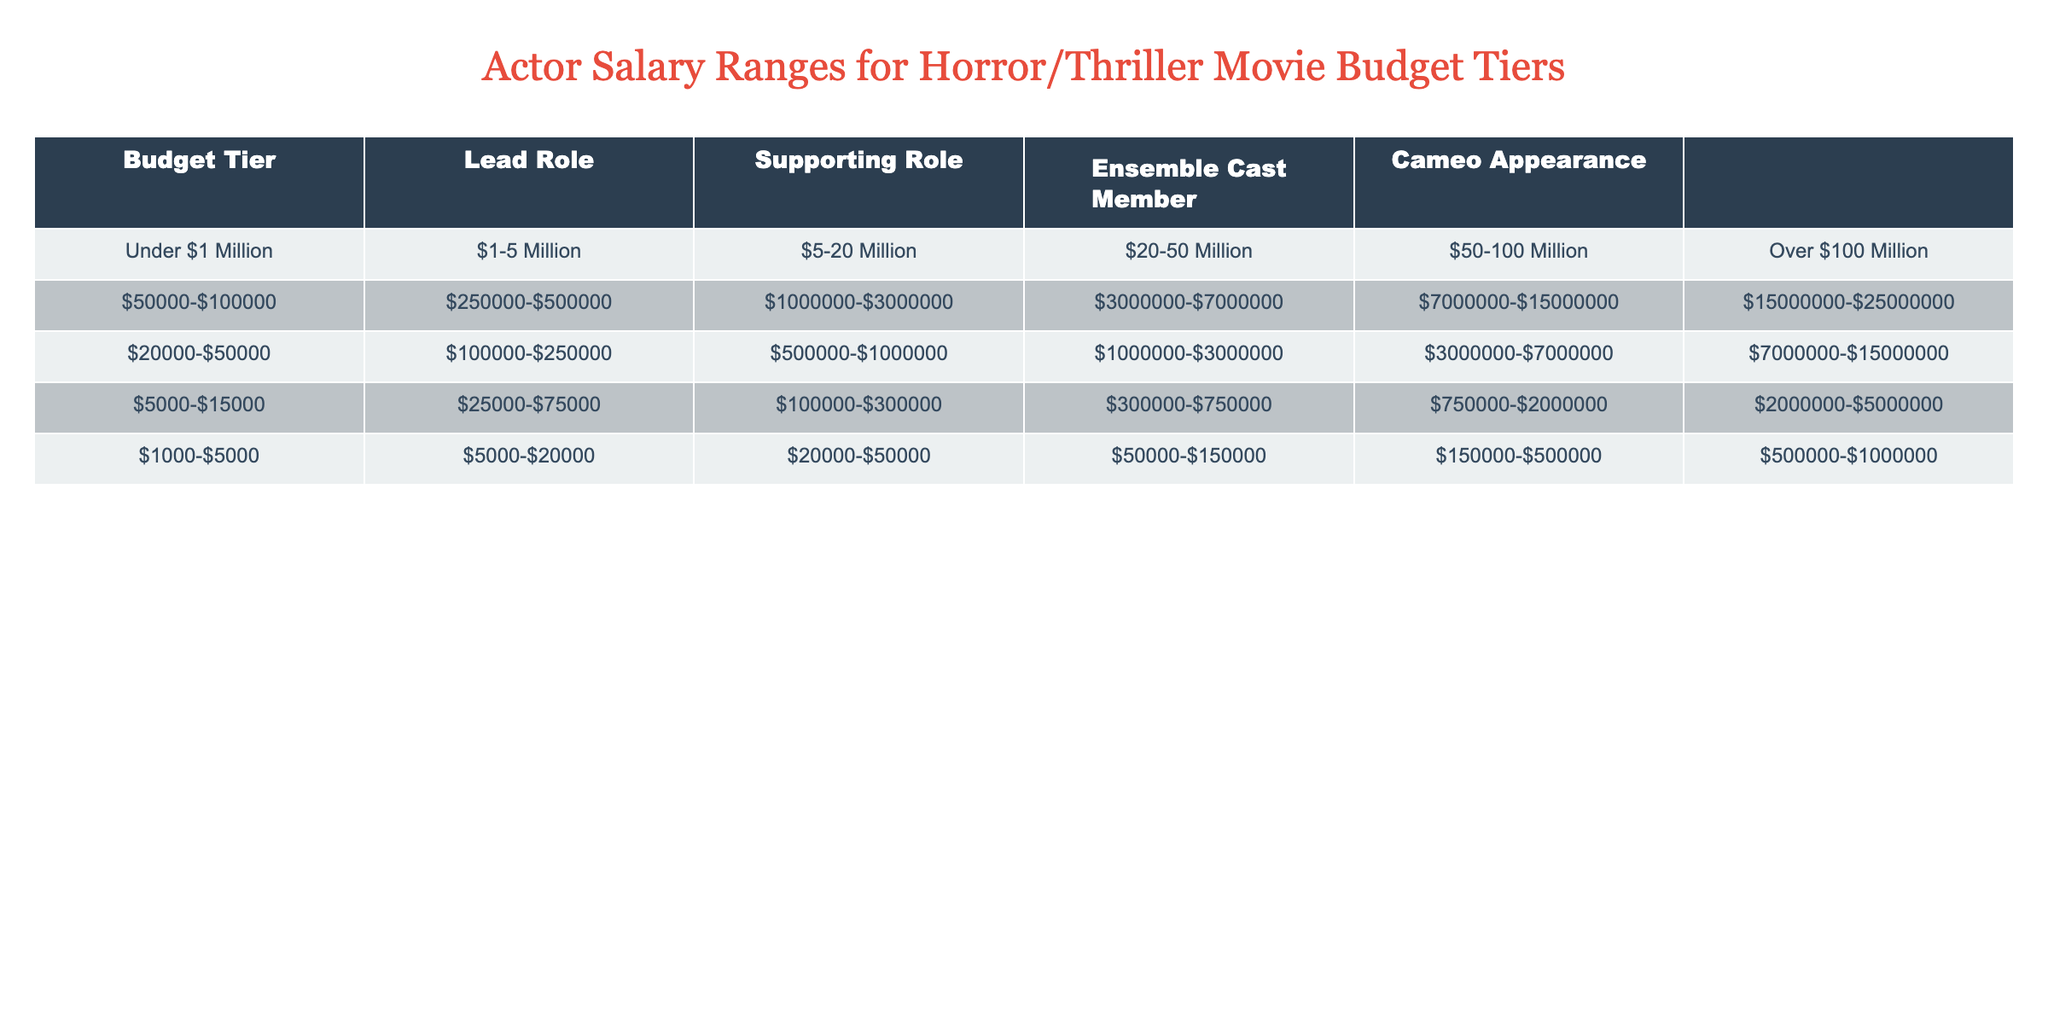What is the salary range for a lead role in movies with a budget of $1-5 million? According to the table, the salary range for a lead role in the $1-5 million budget tier is $250,000 to $500,000
Answer: $250,000-$500,000 What is the salary range for a cameo appearance in films with a budget over $100 million? The table shows that for a cameo appearance in movies with a budget over $100 million, the salary range is $500,000 to $1,000,000
Answer: $500,000-$1,000,000 For a movie budgeted between $5-20 million, how much does an ensemble cast member earn on average? The salary range for an ensemble cast member is $100,000 to $300,000. To find the average, sum the min and max values: (100,000 + 300,000) / 2 = 200,000
Answer: $200,000 Is the salary for a supporting role in the $20-50 million budget tier higher than in the $1-5 million tier? Yes, the supporting role salary in the $20-50 million tier is $1,000,000 to $3,000,000, which is significantly higher than the $100,000 to $250,000 range in the $1-5 million tier
Answer: Yes What is the difference in the maximum salary between a lead role in the $50-100 million tier and a supporting role in the $5-20 million tier? The maximum salary for a lead role in the $50-100 million tier is $15,000,000, while the maximum for a supporting role in the $5-20 million tier is $1,000,000. The difference is $15,000,000 - $1,000,000 = $14,000,000
Answer: $14,000,000 For a cameo appearance in a film with a budget of $20 million, is it possible to earn more than $100,000? No, the salary for a cameo appearance in the $20-50 million budget tier ranges between $50,000 and $150,000, which does not reach $100,000
Answer: No What is the combined salary range for a lead role in the under $1 million tier and a supporting role in the $5-20 million tier? The lead role in the under $1 million tier has a salary range of $50,000 to $100,000, and the supporting role in the $5-20 million tier ranges from $500,000 to $1,000,000. The combined range would go from $50,000 + $500,000 = $550,000 to $100,000 + $1,000,000 = $1,100,000
Answer: $550,000-$1,100,000 What percentage of the maximum salary for an ensemble cast member in the over $100 million tier is represented by the minimum salary for a supporting role in the $50-100 million tier? The maximum salary for an ensemble cast member in the over $100 million tier is $5,000,000. The minimum salary for a supporting role in the $50-100 million tier is $3,000,000. To find the percentage, calculate (3,000,000 / 5,000,000) * 100 = 60%
Answer: 60% Is it true that for every budget tier, the lead role always has a higher salary range than the supporting role? Yes, in every budget tier listed, the lead role salary range is consistently higher than that of the supporting role
Answer: Yes 